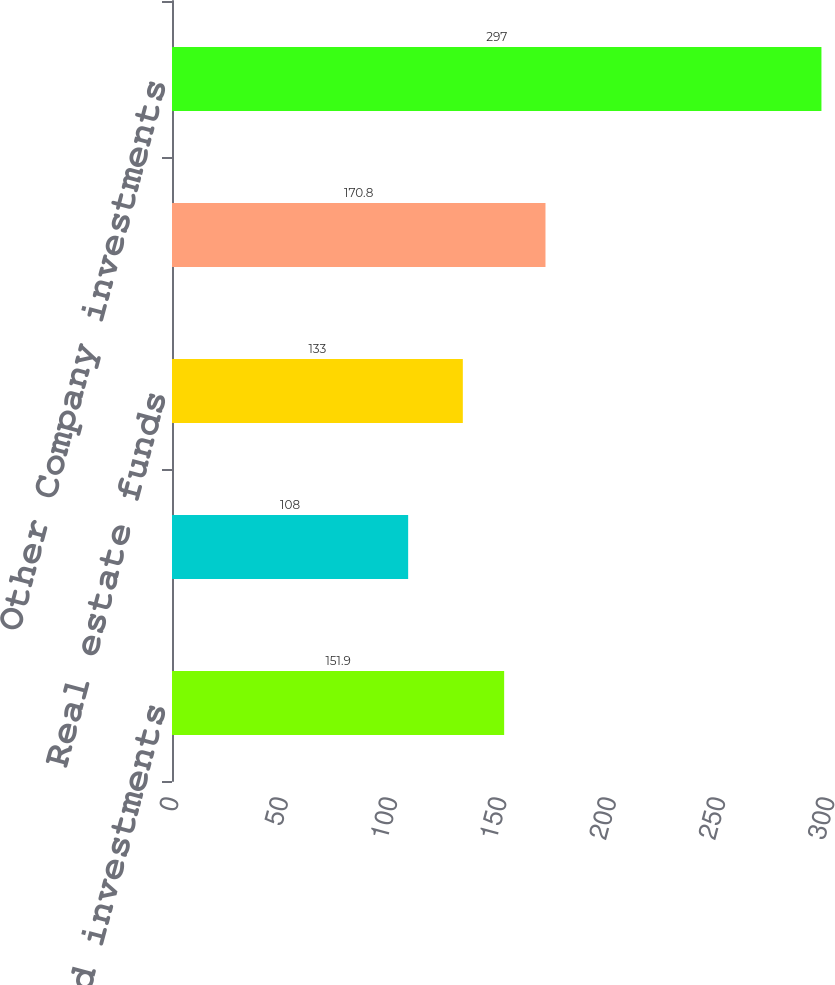Convert chart to OTSL. <chart><loc_0><loc_0><loc_500><loc_500><bar_chart><fcel>Hedge fund investments<fcel>Private equity and<fcel>Real estate funds<fcel>Mitsubishi UFJ Morgan Stanley<fcel>Other Company investments<nl><fcel>151.9<fcel>108<fcel>133<fcel>170.8<fcel>297<nl></chart> 